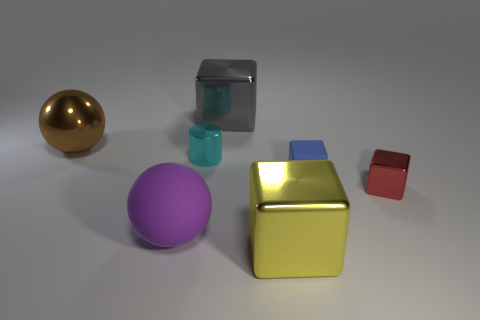Subtract 2 cubes. How many cubes are left? 2 Subtract all brown cubes. Subtract all cyan balls. How many cubes are left? 4 Add 2 big yellow matte things. How many objects exist? 9 Subtract all blocks. How many objects are left? 3 Subtract all small blue spheres. Subtract all big metal things. How many objects are left? 4 Add 7 big brown balls. How many big brown balls are left? 8 Add 5 big gray metal objects. How many big gray metal objects exist? 6 Subtract 0 purple cylinders. How many objects are left? 7 